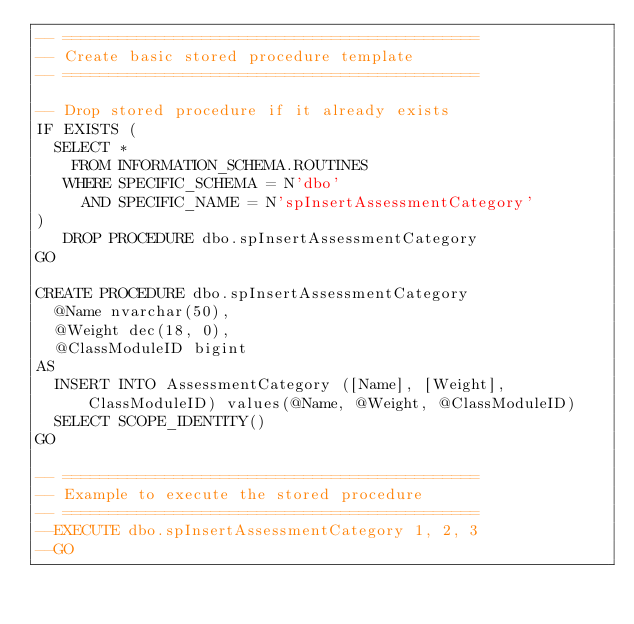Convert code to text. <code><loc_0><loc_0><loc_500><loc_500><_SQL_>-- =============================================
-- Create basic stored procedure template
-- =============================================

-- Drop stored procedure if it already exists
IF EXISTS (
  SELECT * 
    FROM INFORMATION_SCHEMA.ROUTINES 
   WHERE SPECIFIC_SCHEMA = N'dbo'
     AND SPECIFIC_NAME = N'spInsertAssessmentCategory' 
)
   DROP PROCEDURE dbo.spInsertAssessmentCategory
GO

CREATE PROCEDURE dbo.spInsertAssessmentCategory
	@Name nvarchar(50), 
	@Weight dec(18, 0),
	@ClassModuleID bigint
AS
	INSERT INTO AssessmentCategory ([Name], [Weight], ClassModuleID) values(@Name, @Weight, @ClassModuleID)
	SELECT SCOPE_IDENTITY()
GO

-- =============================================
-- Example to execute the stored procedure
-- =============================================
--EXECUTE dbo.spInsertAssessmentCategory 1, 2, 3
--GO
</code> 